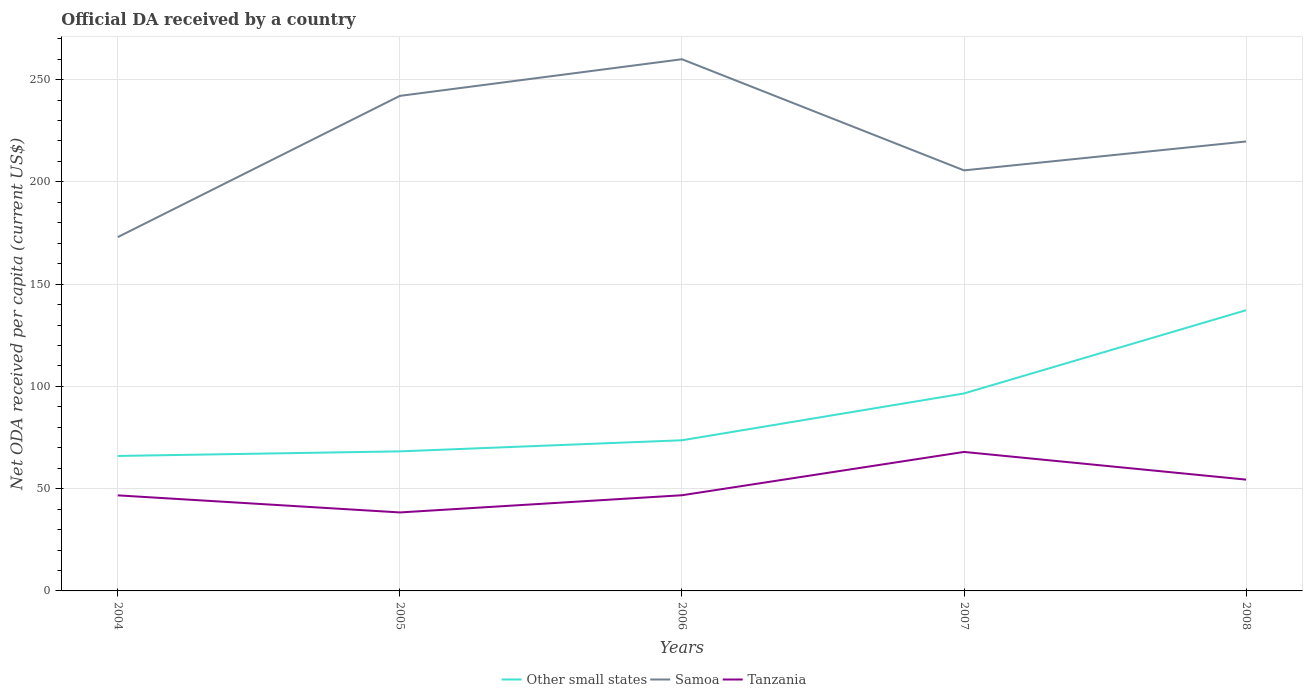Does the line corresponding to Samoa intersect with the line corresponding to Other small states?
Give a very brief answer. No. Across all years, what is the maximum ODA received in in Other small states?
Keep it short and to the point. 65.99. What is the total ODA received in in Samoa in the graph?
Your response must be concise. 22.3. What is the difference between the highest and the second highest ODA received in in Samoa?
Ensure brevity in your answer.  86.96. What is the difference between the highest and the lowest ODA received in in Other small states?
Keep it short and to the point. 2. How many lines are there?
Keep it short and to the point. 3. How many years are there in the graph?
Your answer should be very brief. 5. What is the difference between two consecutive major ticks on the Y-axis?
Provide a short and direct response. 50. Are the values on the major ticks of Y-axis written in scientific E-notation?
Offer a very short reply. No. Does the graph contain any zero values?
Provide a succinct answer. No. Where does the legend appear in the graph?
Ensure brevity in your answer.  Bottom center. How many legend labels are there?
Your response must be concise. 3. What is the title of the graph?
Make the answer very short. Official DA received by a country. Does "Djibouti" appear as one of the legend labels in the graph?
Make the answer very short. No. What is the label or title of the X-axis?
Provide a succinct answer. Years. What is the label or title of the Y-axis?
Make the answer very short. Net ODA received per capita (current US$). What is the Net ODA received per capita (current US$) of Other small states in 2004?
Your answer should be compact. 65.99. What is the Net ODA received per capita (current US$) in Samoa in 2004?
Offer a very short reply. 172.99. What is the Net ODA received per capita (current US$) in Tanzania in 2004?
Give a very brief answer. 46.72. What is the Net ODA received per capita (current US$) in Other small states in 2005?
Provide a short and direct response. 68.23. What is the Net ODA received per capita (current US$) in Samoa in 2005?
Ensure brevity in your answer.  242.04. What is the Net ODA received per capita (current US$) of Tanzania in 2005?
Provide a short and direct response. 38.37. What is the Net ODA received per capita (current US$) in Other small states in 2006?
Offer a very short reply. 73.66. What is the Net ODA received per capita (current US$) of Samoa in 2006?
Keep it short and to the point. 259.95. What is the Net ODA received per capita (current US$) of Tanzania in 2006?
Ensure brevity in your answer.  46.78. What is the Net ODA received per capita (current US$) of Other small states in 2007?
Provide a short and direct response. 96.55. What is the Net ODA received per capita (current US$) of Samoa in 2007?
Your answer should be very brief. 205.61. What is the Net ODA received per capita (current US$) of Tanzania in 2007?
Your response must be concise. 67.95. What is the Net ODA received per capita (current US$) in Other small states in 2008?
Your answer should be very brief. 137.24. What is the Net ODA received per capita (current US$) in Samoa in 2008?
Offer a very short reply. 219.74. What is the Net ODA received per capita (current US$) of Tanzania in 2008?
Give a very brief answer. 54.42. Across all years, what is the maximum Net ODA received per capita (current US$) in Other small states?
Provide a succinct answer. 137.24. Across all years, what is the maximum Net ODA received per capita (current US$) of Samoa?
Give a very brief answer. 259.95. Across all years, what is the maximum Net ODA received per capita (current US$) of Tanzania?
Make the answer very short. 67.95. Across all years, what is the minimum Net ODA received per capita (current US$) in Other small states?
Your answer should be compact. 65.99. Across all years, what is the minimum Net ODA received per capita (current US$) of Samoa?
Provide a short and direct response. 172.99. Across all years, what is the minimum Net ODA received per capita (current US$) of Tanzania?
Your answer should be compact. 38.37. What is the total Net ODA received per capita (current US$) of Other small states in the graph?
Offer a terse response. 441.67. What is the total Net ODA received per capita (current US$) in Samoa in the graph?
Your answer should be very brief. 1100.34. What is the total Net ODA received per capita (current US$) in Tanzania in the graph?
Make the answer very short. 254.24. What is the difference between the Net ODA received per capita (current US$) of Other small states in 2004 and that in 2005?
Give a very brief answer. -2.25. What is the difference between the Net ODA received per capita (current US$) of Samoa in 2004 and that in 2005?
Your answer should be compact. -69.05. What is the difference between the Net ODA received per capita (current US$) in Tanzania in 2004 and that in 2005?
Your answer should be compact. 8.35. What is the difference between the Net ODA received per capita (current US$) of Other small states in 2004 and that in 2006?
Provide a succinct answer. -7.67. What is the difference between the Net ODA received per capita (current US$) of Samoa in 2004 and that in 2006?
Offer a very short reply. -86.96. What is the difference between the Net ODA received per capita (current US$) in Tanzania in 2004 and that in 2006?
Your response must be concise. -0.06. What is the difference between the Net ODA received per capita (current US$) of Other small states in 2004 and that in 2007?
Ensure brevity in your answer.  -30.56. What is the difference between the Net ODA received per capita (current US$) in Samoa in 2004 and that in 2007?
Offer a very short reply. -32.62. What is the difference between the Net ODA received per capita (current US$) in Tanzania in 2004 and that in 2007?
Provide a short and direct response. -21.23. What is the difference between the Net ODA received per capita (current US$) of Other small states in 2004 and that in 2008?
Provide a short and direct response. -71.25. What is the difference between the Net ODA received per capita (current US$) of Samoa in 2004 and that in 2008?
Your response must be concise. -46.75. What is the difference between the Net ODA received per capita (current US$) of Tanzania in 2004 and that in 2008?
Your answer should be compact. -7.69. What is the difference between the Net ODA received per capita (current US$) of Other small states in 2005 and that in 2006?
Keep it short and to the point. -5.43. What is the difference between the Net ODA received per capita (current US$) in Samoa in 2005 and that in 2006?
Offer a terse response. -17.91. What is the difference between the Net ODA received per capita (current US$) in Tanzania in 2005 and that in 2006?
Your answer should be very brief. -8.4. What is the difference between the Net ODA received per capita (current US$) of Other small states in 2005 and that in 2007?
Make the answer very short. -28.32. What is the difference between the Net ODA received per capita (current US$) of Samoa in 2005 and that in 2007?
Ensure brevity in your answer.  36.43. What is the difference between the Net ODA received per capita (current US$) of Tanzania in 2005 and that in 2007?
Your response must be concise. -29.58. What is the difference between the Net ODA received per capita (current US$) of Other small states in 2005 and that in 2008?
Give a very brief answer. -69.01. What is the difference between the Net ODA received per capita (current US$) of Samoa in 2005 and that in 2008?
Your answer should be very brief. 22.3. What is the difference between the Net ODA received per capita (current US$) of Tanzania in 2005 and that in 2008?
Provide a succinct answer. -16.04. What is the difference between the Net ODA received per capita (current US$) in Other small states in 2006 and that in 2007?
Your answer should be very brief. -22.89. What is the difference between the Net ODA received per capita (current US$) in Samoa in 2006 and that in 2007?
Keep it short and to the point. 54.34. What is the difference between the Net ODA received per capita (current US$) of Tanzania in 2006 and that in 2007?
Offer a terse response. -21.18. What is the difference between the Net ODA received per capita (current US$) in Other small states in 2006 and that in 2008?
Your response must be concise. -63.58. What is the difference between the Net ODA received per capita (current US$) in Samoa in 2006 and that in 2008?
Provide a succinct answer. 40.21. What is the difference between the Net ODA received per capita (current US$) of Tanzania in 2006 and that in 2008?
Offer a very short reply. -7.64. What is the difference between the Net ODA received per capita (current US$) in Other small states in 2007 and that in 2008?
Keep it short and to the point. -40.69. What is the difference between the Net ODA received per capita (current US$) in Samoa in 2007 and that in 2008?
Give a very brief answer. -14.13. What is the difference between the Net ODA received per capita (current US$) in Tanzania in 2007 and that in 2008?
Offer a very short reply. 13.54. What is the difference between the Net ODA received per capita (current US$) in Other small states in 2004 and the Net ODA received per capita (current US$) in Samoa in 2005?
Give a very brief answer. -176.06. What is the difference between the Net ODA received per capita (current US$) of Other small states in 2004 and the Net ODA received per capita (current US$) of Tanzania in 2005?
Give a very brief answer. 27.61. What is the difference between the Net ODA received per capita (current US$) of Samoa in 2004 and the Net ODA received per capita (current US$) of Tanzania in 2005?
Your answer should be compact. 134.62. What is the difference between the Net ODA received per capita (current US$) of Other small states in 2004 and the Net ODA received per capita (current US$) of Samoa in 2006?
Ensure brevity in your answer.  -193.97. What is the difference between the Net ODA received per capita (current US$) of Other small states in 2004 and the Net ODA received per capita (current US$) of Tanzania in 2006?
Ensure brevity in your answer.  19.21. What is the difference between the Net ODA received per capita (current US$) of Samoa in 2004 and the Net ODA received per capita (current US$) of Tanzania in 2006?
Your response must be concise. 126.22. What is the difference between the Net ODA received per capita (current US$) in Other small states in 2004 and the Net ODA received per capita (current US$) in Samoa in 2007?
Your answer should be compact. -139.62. What is the difference between the Net ODA received per capita (current US$) of Other small states in 2004 and the Net ODA received per capita (current US$) of Tanzania in 2007?
Your response must be concise. -1.97. What is the difference between the Net ODA received per capita (current US$) in Samoa in 2004 and the Net ODA received per capita (current US$) in Tanzania in 2007?
Offer a terse response. 105.04. What is the difference between the Net ODA received per capita (current US$) of Other small states in 2004 and the Net ODA received per capita (current US$) of Samoa in 2008?
Make the answer very short. -153.76. What is the difference between the Net ODA received per capita (current US$) of Other small states in 2004 and the Net ODA received per capita (current US$) of Tanzania in 2008?
Ensure brevity in your answer.  11.57. What is the difference between the Net ODA received per capita (current US$) of Samoa in 2004 and the Net ODA received per capita (current US$) of Tanzania in 2008?
Your answer should be compact. 118.58. What is the difference between the Net ODA received per capita (current US$) of Other small states in 2005 and the Net ODA received per capita (current US$) of Samoa in 2006?
Ensure brevity in your answer.  -191.72. What is the difference between the Net ODA received per capita (current US$) of Other small states in 2005 and the Net ODA received per capita (current US$) of Tanzania in 2006?
Keep it short and to the point. 21.45. What is the difference between the Net ODA received per capita (current US$) in Samoa in 2005 and the Net ODA received per capita (current US$) in Tanzania in 2006?
Keep it short and to the point. 195.26. What is the difference between the Net ODA received per capita (current US$) in Other small states in 2005 and the Net ODA received per capita (current US$) in Samoa in 2007?
Ensure brevity in your answer.  -137.38. What is the difference between the Net ODA received per capita (current US$) of Other small states in 2005 and the Net ODA received per capita (current US$) of Tanzania in 2007?
Ensure brevity in your answer.  0.28. What is the difference between the Net ODA received per capita (current US$) in Samoa in 2005 and the Net ODA received per capita (current US$) in Tanzania in 2007?
Your answer should be very brief. 174.09. What is the difference between the Net ODA received per capita (current US$) of Other small states in 2005 and the Net ODA received per capita (current US$) of Samoa in 2008?
Your response must be concise. -151.51. What is the difference between the Net ODA received per capita (current US$) in Other small states in 2005 and the Net ODA received per capita (current US$) in Tanzania in 2008?
Provide a short and direct response. 13.81. What is the difference between the Net ODA received per capita (current US$) of Samoa in 2005 and the Net ODA received per capita (current US$) of Tanzania in 2008?
Provide a succinct answer. 187.62. What is the difference between the Net ODA received per capita (current US$) in Other small states in 2006 and the Net ODA received per capita (current US$) in Samoa in 2007?
Your answer should be very brief. -131.95. What is the difference between the Net ODA received per capita (current US$) of Other small states in 2006 and the Net ODA received per capita (current US$) of Tanzania in 2007?
Your answer should be compact. 5.71. What is the difference between the Net ODA received per capita (current US$) in Samoa in 2006 and the Net ODA received per capita (current US$) in Tanzania in 2007?
Ensure brevity in your answer.  192. What is the difference between the Net ODA received per capita (current US$) of Other small states in 2006 and the Net ODA received per capita (current US$) of Samoa in 2008?
Your answer should be compact. -146.08. What is the difference between the Net ODA received per capita (current US$) of Other small states in 2006 and the Net ODA received per capita (current US$) of Tanzania in 2008?
Your answer should be compact. 19.24. What is the difference between the Net ODA received per capita (current US$) in Samoa in 2006 and the Net ODA received per capita (current US$) in Tanzania in 2008?
Offer a very short reply. 205.54. What is the difference between the Net ODA received per capita (current US$) of Other small states in 2007 and the Net ODA received per capita (current US$) of Samoa in 2008?
Offer a very short reply. -123.2. What is the difference between the Net ODA received per capita (current US$) of Other small states in 2007 and the Net ODA received per capita (current US$) of Tanzania in 2008?
Your answer should be very brief. 42.13. What is the difference between the Net ODA received per capita (current US$) of Samoa in 2007 and the Net ODA received per capita (current US$) of Tanzania in 2008?
Provide a succinct answer. 151.19. What is the average Net ODA received per capita (current US$) of Other small states per year?
Your answer should be compact. 88.33. What is the average Net ODA received per capita (current US$) of Samoa per year?
Provide a succinct answer. 220.07. What is the average Net ODA received per capita (current US$) of Tanzania per year?
Your answer should be very brief. 50.85. In the year 2004, what is the difference between the Net ODA received per capita (current US$) in Other small states and Net ODA received per capita (current US$) in Samoa?
Your answer should be very brief. -107.01. In the year 2004, what is the difference between the Net ODA received per capita (current US$) of Other small states and Net ODA received per capita (current US$) of Tanzania?
Give a very brief answer. 19.26. In the year 2004, what is the difference between the Net ODA received per capita (current US$) in Samoa and Net ODA received per capita (current US$) in Tanzania?
Your answer should be very brief. 126.27. In the year 2005, what is the difference between the Net ODA received per capita (current US$) in Other small states and Net ODA received per capita (current US$) in Samoa?
Your response must be concise. -173.81. In the year 2005, what is the difference between the Net ODA received per capita (current US$) in Other small states and Net ODA received per capita (current US$) in Tanzania?
Offer a very short reply. 29.86. In the year 2005, what is the difference between the Net ODA received per capita (current US$) of Samoa and Net ODA received per capita (current US$) of Tanzania?
Make the answer very short. 203.67. In the year 2006, what is the difference between the Net ODA received per capita (current US$) in Other small states and Net ODA received per capita (current US$) in Samoa?
Offer a very short reply. -186.29. In the year 2006, what is the difference between the Net ODA received per capita (current US$) in Other small states and Net ODA received per capita (current US$) in Tanzania?
Provide a succinct answer. 26.88. In the year 2006, what is the difference between the Net ODA received per capita (current US$) in Samoa and Net ODA received per capita (current US$) in Tanzania?
Keep it short and to the point. 213.17. In the year 2007, what is the difference between the Net ODA received per capita (current US$) in Other small states and Net ODA received per capita (current US$) in Samoa?
Provide a short and direct response. -109.06. In the year 2007, what is the difference between the Net ODA received per capita (current US$) of Other small states and Net ODA received per capita (current US$) of Tanzania?
Your response must be concise. 28.59. In the year 2007, what is the difference between the Net ODA received per capita (current US$) of Samoa and Net ODA received per capita (current US$) of Tanzania?
Give a very brief answer. 137.66. In the year 2008, what is the difference between the Net ODA received per capita (current US$) in Other small states and Net ODA received per capita (current US$) in Samoa?
Your answer should be compact. -82.5. In the year 2008, what is the difference between the Net ODA received per capita (current US$) in Other small states and Net ODA received per capita (current US$) in Tanzania?
Ensure brevity in your answer.  82.82. In the year 2008, what is the difference between the Net ODA received per capita (current US$) of Samoa and Net ODA received per capita (current US$) of Tanzania?
Your answer should be very brief. 165.33. What is the ratio of the Net ODA received per capita (current US$) in Other small states in 2004 to that in 2005?
Your answer should be compact. 0.97. What is the ratio of the Net ODA received per capita (current US$) of Samoa in 2004 to that in 2005?
Your answer should be very brief. 0.71. What is the ratio of the Net ODA received per capita (current US$) in Tanzania in 2004 to that in 2005?
Provide a succinct answer. 1.22. What is the ratio of the Net ODA received per capita (current US$) of Other small states in 2004 to that in 2006?
Offer a very short reply. 0.9. What is the ratio of the Net ODA received per capita (current US$) in Samoa in 2004 to that in 2006?
Keep it short and to the point. 0.67. What is the ratio of the Net ODA received per capita (current US$) in Other small states in 2004 to that in 2007?
Make the answer very short. 0.68. What is the ratio of the Net ODA received per capita (current US$) in Samoa in 2004 to that in 2007?
Keep it short and to the point. 0.84. What is the ratio of the Net ODA received per capita (current US$) of Tanzania in 2004 to that in 2007?
Offer a terse response. 0.69. What is the ratio of the Net ODA received per capita (current US$) in Other small states in 2004 to that in 2008?
Your answer should be compact. 0.48. What is the ratio of the Net ODA received per capita (current US$) of Samoa in 2004 to that in 2008?
Offer a very short reply. 0.79. What is the ratio of the Net ODA received per capita (current US$) in Tanzania in 2004 to that in 2008?
Offer a very short reply. 0.86. What is the ratio of the Net ODA received per capita (current US$) of Other small states in 2005 to that in 2006?
Offer a very short reply. 0.93. What is the ratio of the Net ODA received per capita (current US$) of Samoa in 2005 to that in 2006?
Provide a succinct answer. 0.93. What is the ratio of the Net ODA received per capita (current US$) in Tanzania in 2005 to that in 2006?
Ensure brevity in your answer.  0.82. What is the ratio of the Net ODA received per capita (current US$) of Other small states in 2005 to that in 2007?
Your answer should be compact. 0.71. What is the ratio of the Net ODA received per capita (current US$) of Samoa in 2005 to that in 2007?
Provide a succinct answer. 1.18. What is the ratio of the Net ODA received per capita (current US$) of Tanzania in 2005 to that in 2007?
Keep it short and to the point. 0.56. What is the ratio of the Net ODA received per capita (current US$) of Other small states in 2005 to that in 2008?
Your answer should be compact. 0.5. What is the ratio of the Net ODA received per capita (current US$) of Samoa in 2005 to that in 2008?
Your answer should be compact. 1.1. What is the ratio of the Net ODA received per capita (current US$) of Tanzania in 2005 to that in 2008?
Your answer should be compact. 0.71. What is the ratio of the Net ODA received per capita (current US$) of Other small states in 2006 to that in 2007?
Offer a terse response. 0.76. What is the ratio of the Net ODA received per capita (current US$) of Samoa in 2006 to that in 2007?
Provide a succinct answer. 1.26. What is the ratio of the Net ODA received per capita (current US$) in Tanzania in 2006 to that in 2007?
Offer a terse response. 0.69. What is the ratio of the Net ODA received per capita (current US$) in Other small states in 2006 to that in 2008?
Give a very brief answer. 0.54. What is the ratio of the Net ODA received per capita (current US$) of Samoa in 2006 to that in 2008?
Your answer should be very brief. 1.18. What is the ratio of the Net ODA received per capita (current US$) of Tanzania in 2006 to that in 2008?
Give a very brief answer. 0.86. What is the ratio of the Net ODA received per capita (current US$) of Other small states in 2007 to that in 2008?
Offer a very short reply. 0.7. What is the ratio of the Net ODA received per capita (current US$) in Samoa in 2007 to that in 2008?
Offer a very short reply. 0.94. What is the ratio of the Net ODA received per capita (current US$) in Tanzania in 2007 to that in 2008?
Your response must be concise. 1.25. What is the difference between the highest and the second highest Net ODA received per capita (current US$) in Other small states?
Ensure brevity in your answer.  40.69. What is the difference between the highest and the second highest Net ODA received per capita (current US$) of Samoa?
Offer a terse response. 17.91. What is the difference between the highest and the second highest Net ODA received per capita (current US$) in Tanzania?
Your answer should be very brief. 13.54. What is the difference between the highest and the lowest Net ODA received per capita (current US$) of Other small states?
Provide a succinct answer. 71.25. What is the difference between the highest and the lowest Net ODA received per capita (current US$) of Samoa?
Provide a short and direct response. 86.96. What is the difference between the highest and the lowest Net ODA received per capita (current US$) of Tanzania?
Make the answer very short. 29.58. 